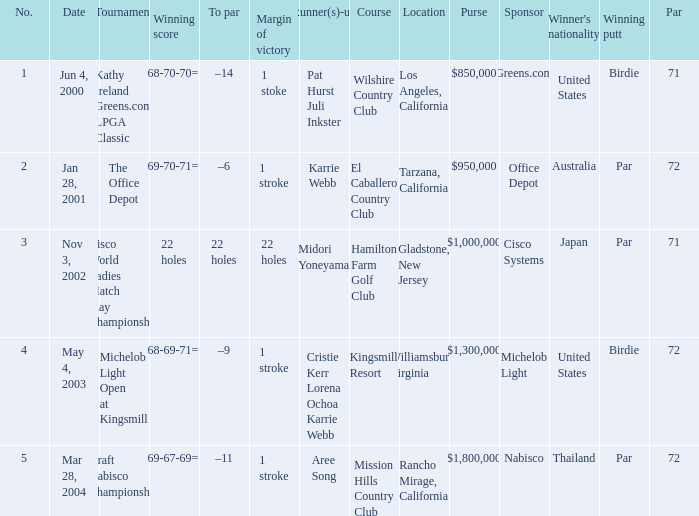Where was the tournament dated nov 3, 2002? Cisco World Ladies Match Play Championship. 